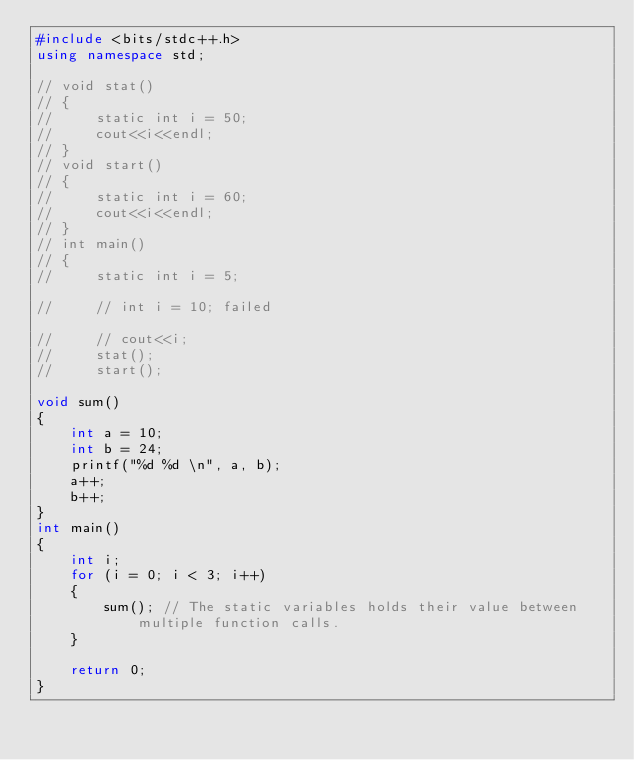<code> <loc_0><loc_0><loc_500><loc_500><_C++_>#include <bits/stdc++.h>
using namespace std;

// void stat()
// {
//     static int i = 50;
//     cout<<i<<endl;
// }
// void start()
// {
//     static int i = 60;
//     cout<<i<<endl;
// }
// int main()
// {
//     static int i = 5;

//     // int i = 10; failed

//     // cout<<i;
//     stat();
//     start();

void sum()
{
    int a = 10;
    int b = 24;
    printf("%d %d \n", a, b);
    a++;
    b++;
}
int main()
{
    int i;
    for (i = 0; i < 3; i++)
    {
        sum(); // The static variables holds their value between multiple function calls.
    }

    return 0;
}</code> 